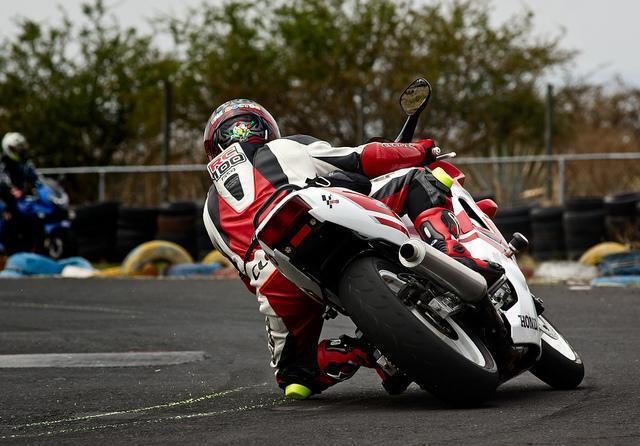How many motorcycles are there?
Give a very brief answer. 2. 